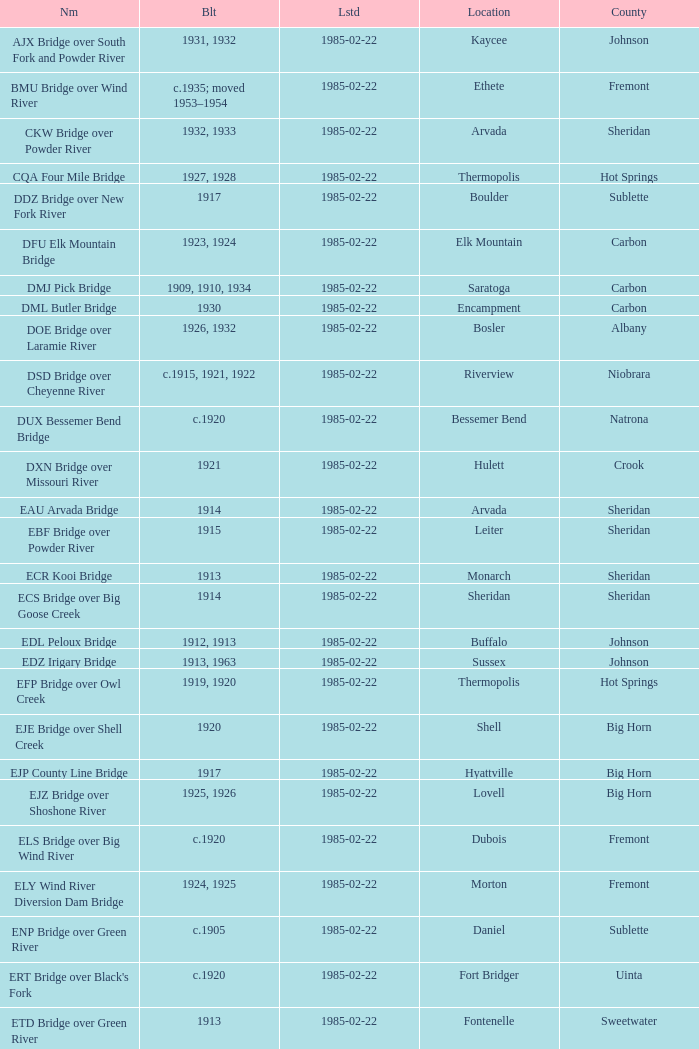What is the county of the bridge in Boulder? Sublette. 